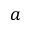<formula> <loc_0><loc_0><loc_500><loc_500>a</formula> 